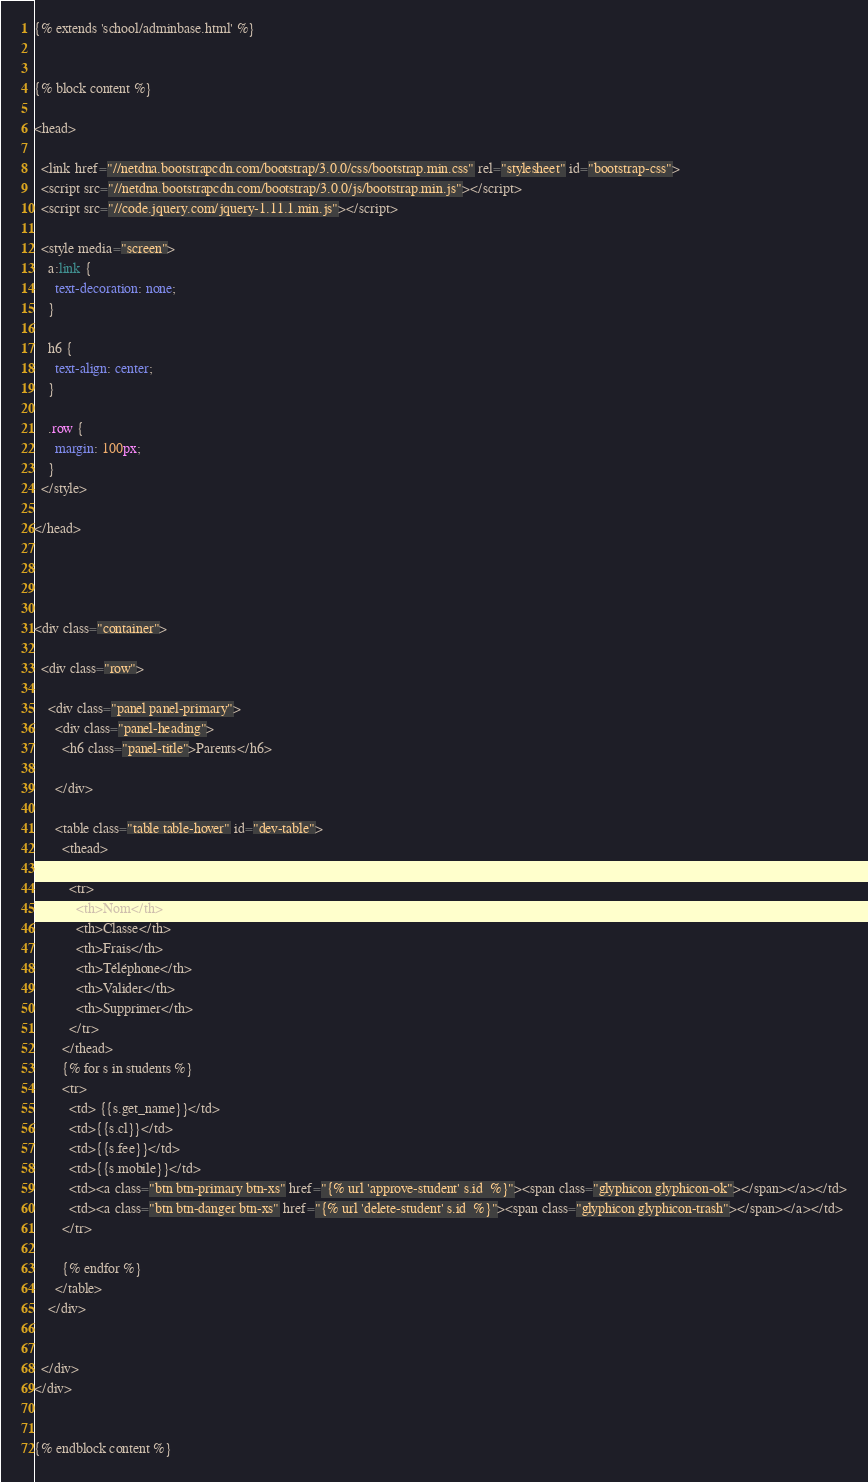<code> <loc_0><loc_0><loc_500><loc_500><_HTML_>{% extends 'school/adminbase.html' %}


{% block content %}

<head>

  <link href="//netdna.bootstrapcdn.com/bootstrap/3.0.0/css/bootstrap.min.css" rel="stylesheet" id="bootstrap-css">
  <script src="//netdna.bootstrapcdn.com/bootstrap/3.0.0/js/bootstrap.min.js"></script>
  <script src="//code.jquery.com/jquery-1.11.1.min.js"></script>

  <style media="screen">
    a:link {
      text-decoration: none;
    }

    h6 {
      text-align: center;
    }

    .row {
      margin: 100px;
    }
  </style>

</head>




<div class="container">

  <div class="row">

    <div class="panel panel-primary">
      <div class="panel-heading">
        <h6 class="panel-title">Parents</h6>

      </div>

      <table class="table table-hover" id="dev-table">
        <thead>

          <tr>
            <th>Nom</th>
            <th>Classe</th>
            <th>Frais</th>
            <th>Téléphone</th>
            <th>Valider</th>
            <th>Supprimer</th>
          </tr>
        </thead>
        {% for s in students %}
        <tr>
          <td> {{s.get_name}}</td>
          <td>{{s.cl}}</td>
          <td>{{s.fee}}</td>
          <td>{{s.mobile}}</td>
          <td><a class="btn btn-primary btn-xs" href="{% url 'approve-student' s.id  %}"><span class="glyphicon glyphicon-ok"></span></a></td>
          <td><a class="btn btn-danger btn-xs" href="{% url 'delete-student' s.id  %}"><span class="glyphicon glyphicon-trash"></span></a></td>
        </tr>

        {% endfor %}
      </table>
    </div>


  </div>
</div>


{% endblock content %}
</code> 